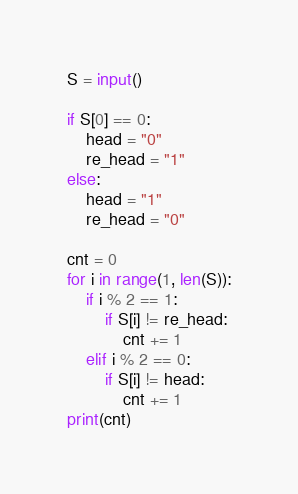Convert code to text. <code><loc_0><loc_0><loc_500><loc_500><_Python_>S = input()

if S[0] == 0:
    head = "0"
    re_head = "1"
else:
    head = "1"
    re_head = "0"

cnt = 0
for i in range(1, len(S)):
    if i % 2 == 1:
        if S[i] != re_head:
            cnt += 1
    elif i % 2 == 0:
        if S[i] != head:
            cnt += 1
print(cnt)
</code> 